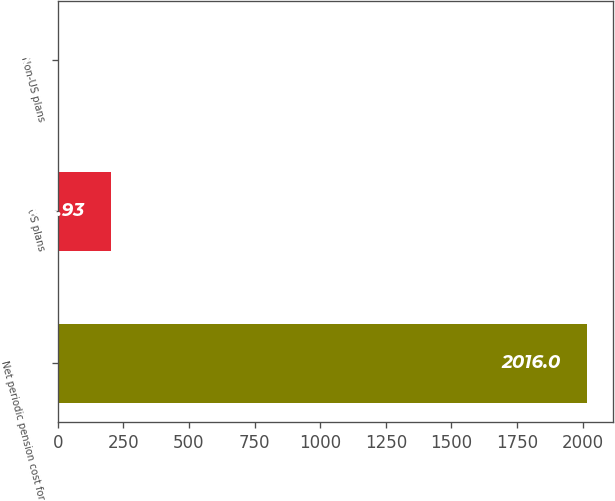<chart> <loc_0><loc_0><loc_500><loc_500><bar_chart><fcel>Net periodic pension cost for<fcel>US plans<fcel>Non-US plans<nl><fcel>2016<fcel>204.93<fcel>3.7<nl></chart> 